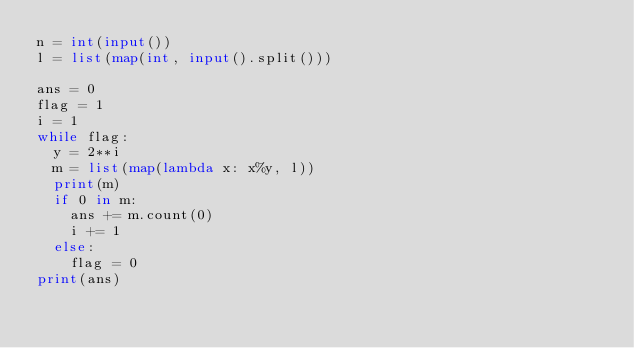<code> <loc_0><loc_0><loc_500><loc_500><_Python_>n = int(input())
l = list(map(int, input().split()))

ans = 0
flag = 1
i = 1
while flag:
  y = 2**i
  m = list(map(lambda x: x%y, l))
  print(m)
  if 0 in m:
    ans += m.count(0)
    i += 1
  else:
    flag = 0
print(ans)</code> 